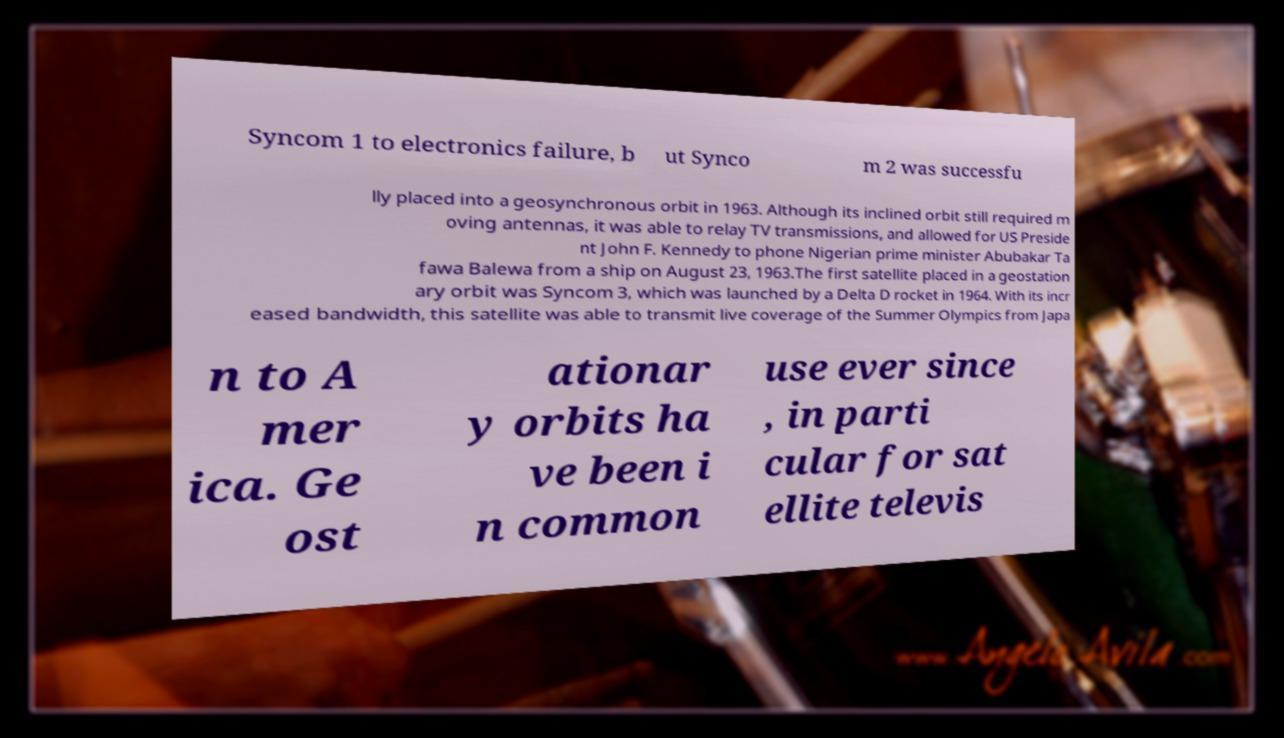I need the written content from this picture converted into text. Can you do that? Syncom 1 to electronics failure, b ut Synco m 2 was successfu lly placed into a geosynchronous orbit in 1963. Although its inclined orbit still required m oving antennas, it was able to relay TV transmissions, and allowed for US Preside nt John F. Kennedy to phone Nigerian prime minister Abubakar Ta fawa Balewa from a ship on August 23, 1963.The first satellite placed in a geostation ary orbit was Syncom 3, which was launched by a Delta D rocket in 1964. With its incr eased bandwidth, this satellite was able to transmit live coverage of the Summer Olympics from Japa n to A mer ica. Ge ost ationar y orbits ha ve been i n common use ever since , in parti cular for sat ellite televis 